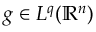Convert formula to latex. <formula><loc_0><loc_0><loc_500><loc_500>g \in L ^ { q } ( \mathbb { R } ^ { n } )</formula> 